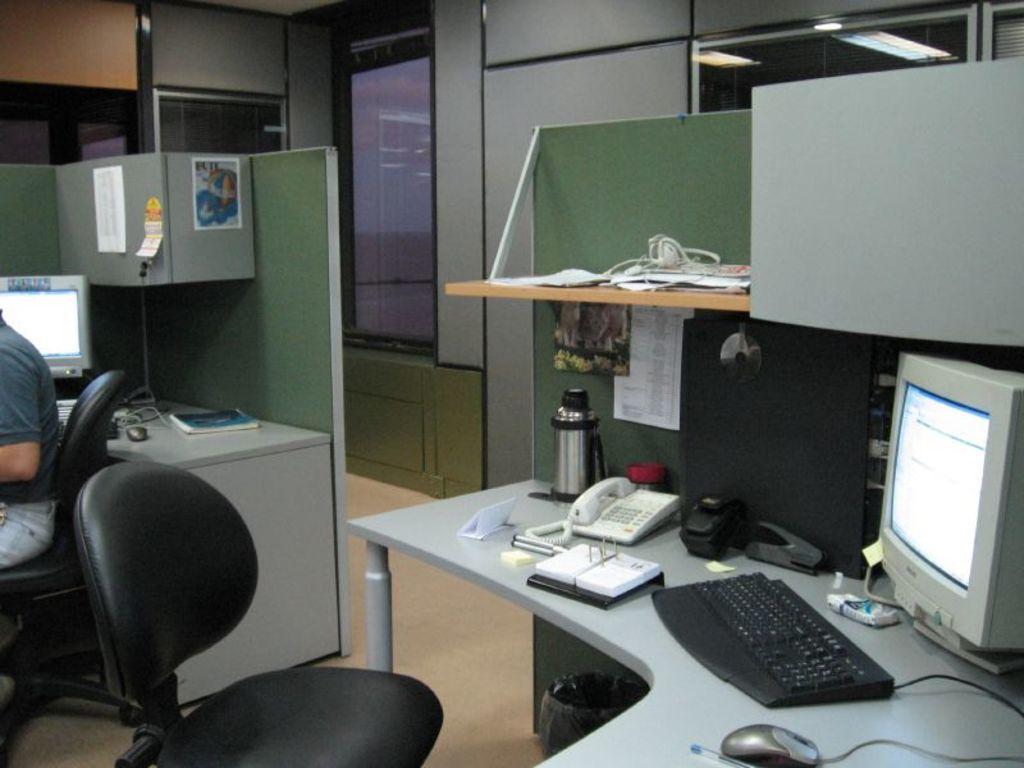Can you describe this image briefly? In the foreground of this image, there is a black chair near a desk on which monitor, keyboard, a flask, a mouse and a pen is placed on it. On left, there is a man on chair near a desk where a monitor, mouse, cable are placed. On top, we see a wall and a glass window. 